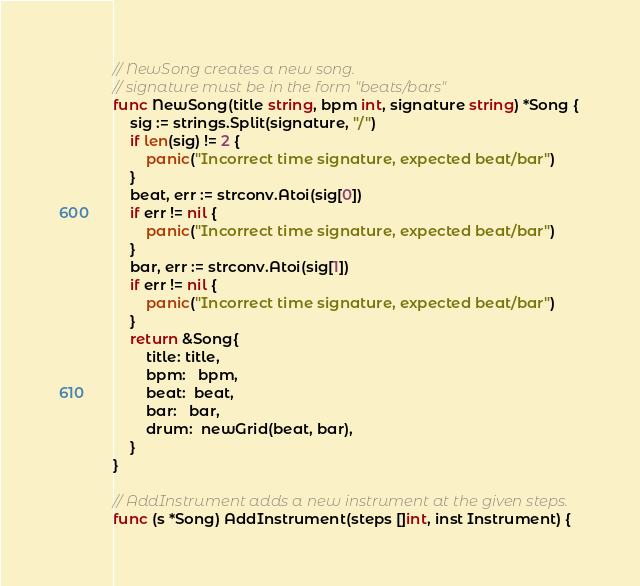<code> <loc_0><loc_0><loc_500><loc_500><_Go_>// NewSong creates a new song.
// signature must be in the form "beats/bars"
func NewSong(title string, bpm int, signature string) *Song {
	sig := strings.Split(signature, "/")
	if len(sig) != 2 {
		panic("Incorrect time signature, expected beat/bar")
	}
	beat, err := strconv.Atoi(sig[0])
	if err != nil {
		panic("Incorrect time signature, expected beat/bar")
	}
	bar, err := strconv.Atoi(sig[1])
	if err != nil {
		panic("Incorrect time signature, expected beat/bar")
	}
	return &Song{
		title: title,
		bpm:   bpm,
		beat:  beat,
		bar:   bar,
		drum:  newGrid(beat, bar),
	}
}

// AddInstrument adds a new instrument at the given steps.
func (s *Song) AddInstrument(steps []int, inst Instrument) {</code> 